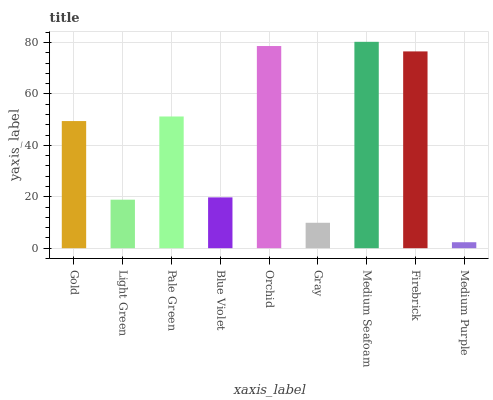Is Medium Purple the minimum?
Answer yes or no. Yes. Is Medium Seafoam the maximum?
Answer yes or no. Yes. Is Light Green the minimum?
Answer yes or no. No. Is Light Green the maximum?
Answer yes or no. No. Is Gold greater than Light Green?
Answer yes or no. Yes. Is Light Green less than Gold?
Answer yes or no. Yes. Is Light Green greater than Gold?
Answer yes or no. No. Is Gold less than Light Green?
Answer yes or no. No. Is Gold the high median?
Answer yes or no. Yes. Is Gold the low median?
Answer yes or no. Yes. Is Light Green the high median?
Answer yes or no. No. Is Light Green the low median?
Answer yes or no. No. 